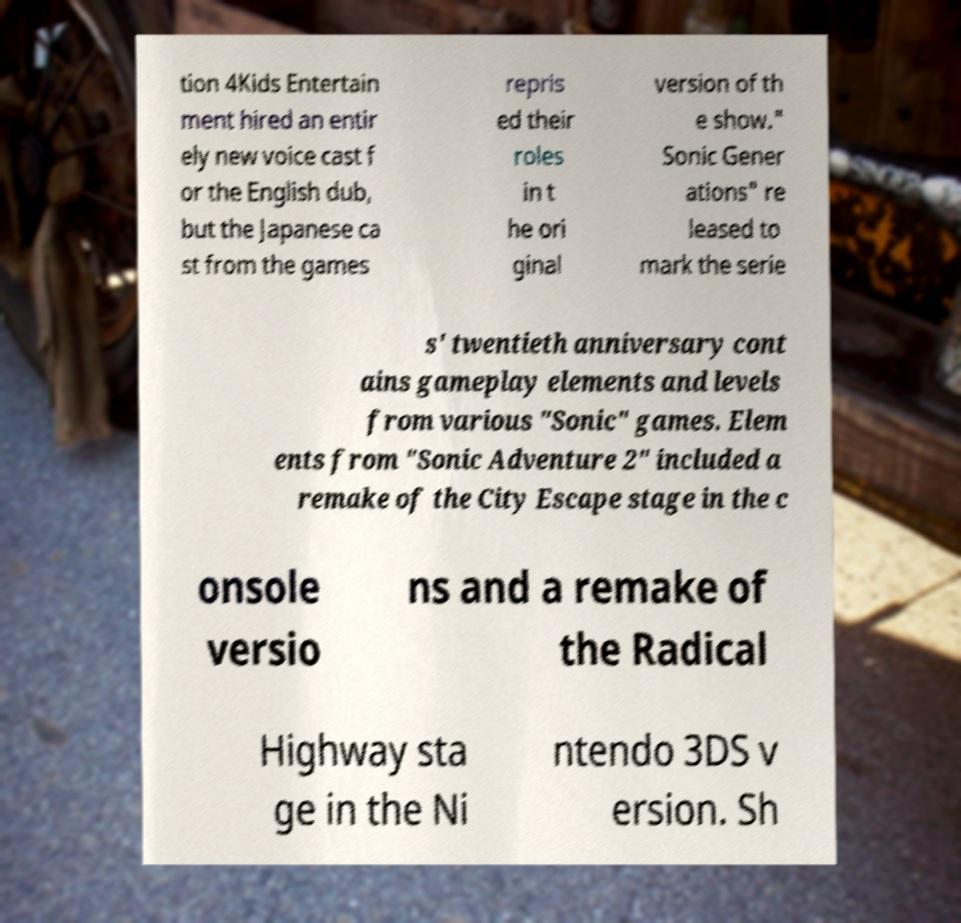Could you extract and type out the text from this image? tion 4Kids Entertain ment hired an entir ely new voice cast f or the English dub, but the Japanese ca st from the games repris ed their roles in t he ori ginal version of th e show." Sonic Gener ations" re leased to mark the serie s' twentieth anniversary cont ains gameplay elements and levels from various "Sonic" games. Elem ents from "Sonic Adventure 2" included a remake of the City Escape stage in the c onsole versio ns and a remake of the Radical Highway sta ge in the Ni ntendo 3DS v ersion. Sh 